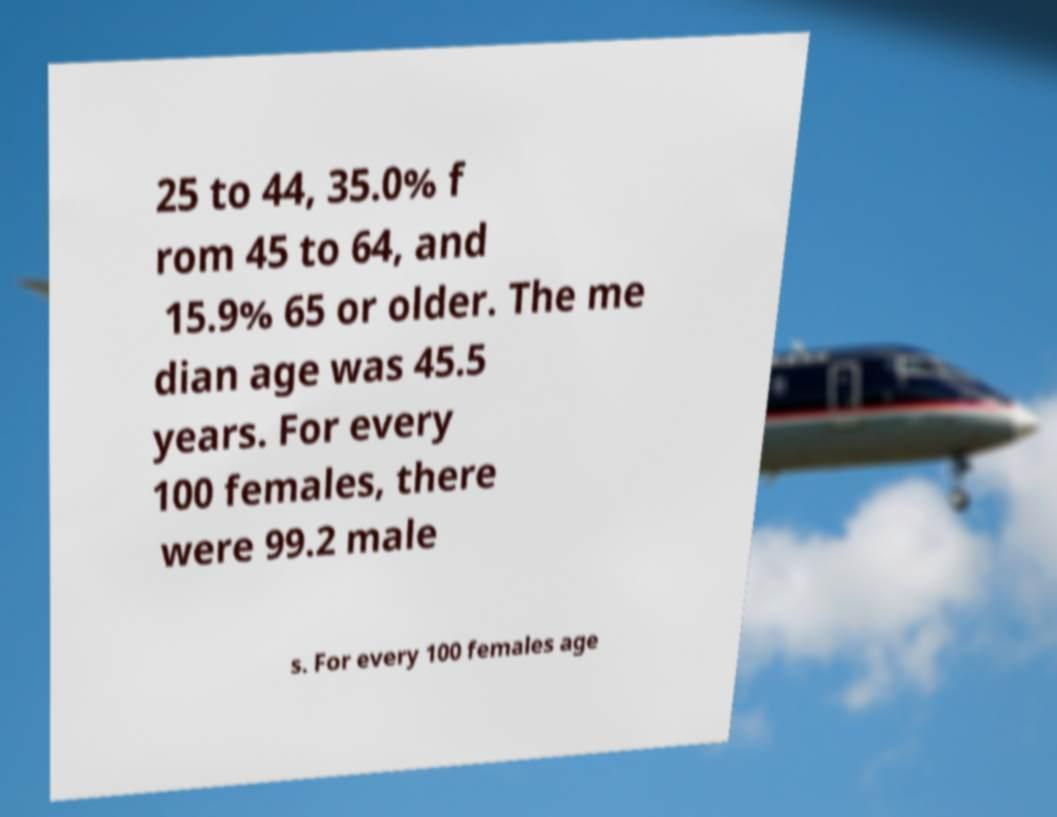Can you accurately transcribe the text from the provided image for me? 25 to 44, 35.0% f rom 45 to 64, and 15.9% 65 or older. The me dian age was 45.5 years. For every 100 females, there were 99.2 male s. For every 100 females age 